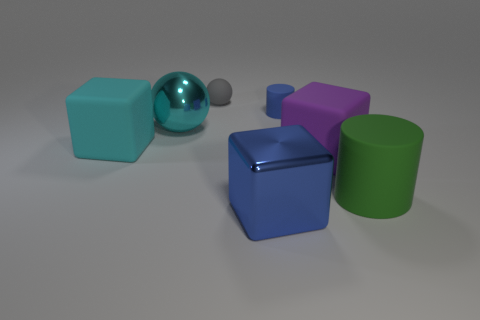Subtract all cyan blocks. Subtract all purple spheres. How many blocks are left? 2 Add 1 tiny gray objects. How many objects exist? 8 Subtract all blocks. How many objects are left? 4 Subtract all cyan metal things. Subtract all large green things. How many objects are left? 5 Add 1 big matte blocks. How many big matte blocks are left? 3 Add 1 blue rubber objects. How many blue rubber objects exist? 2 Subtract 0 cyan cylinders. How many objects are left? 7 